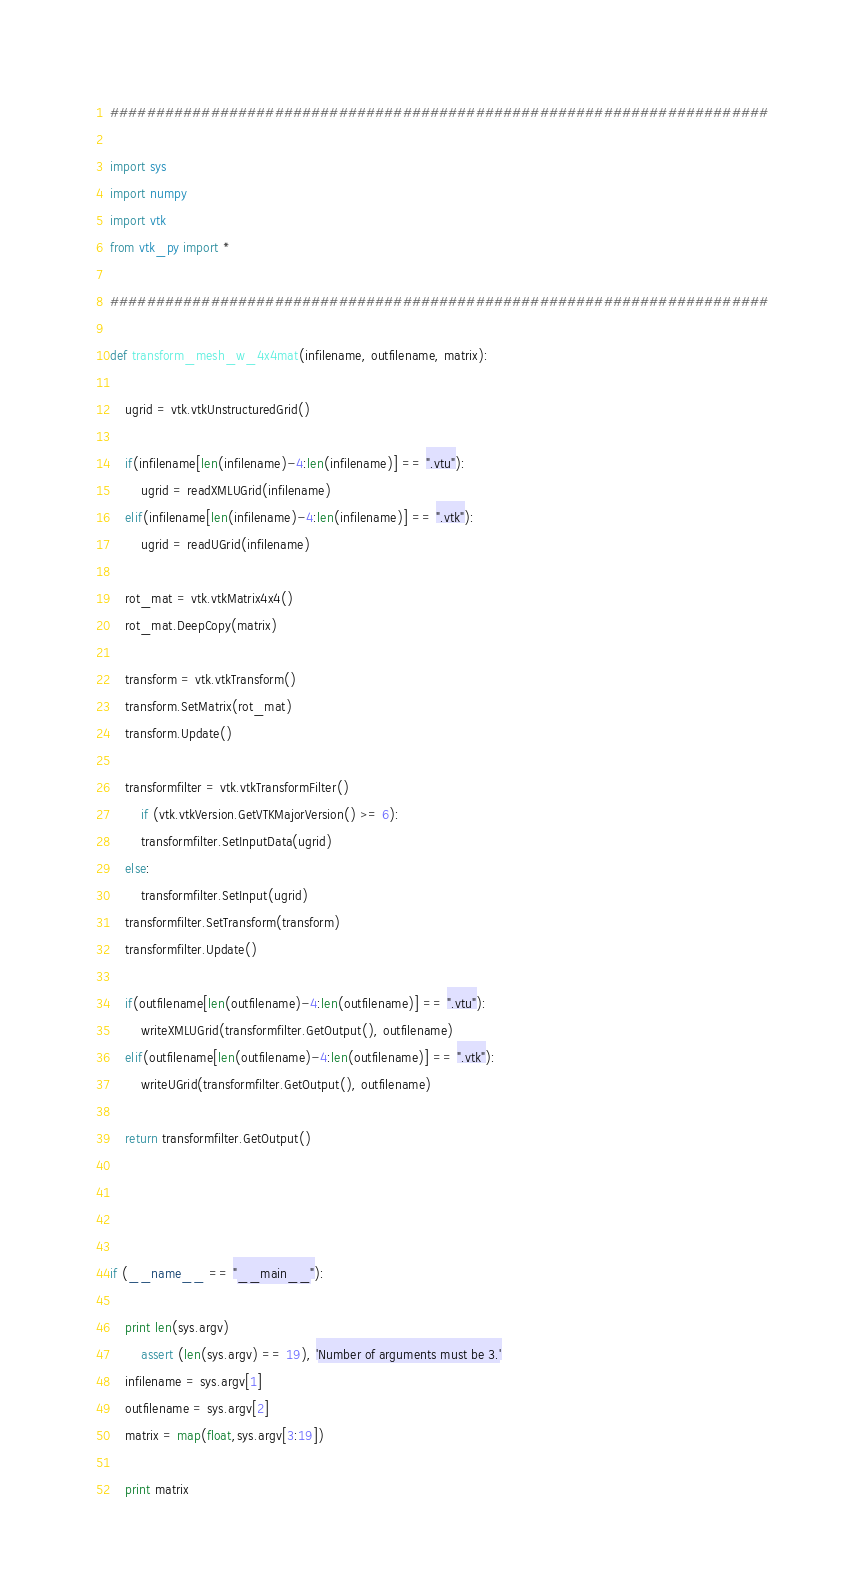Convert code to text. <code><loc_0><loc_0><loc_500><loc_500><_Python_>########################################################################

import sys
import numpy
import vtk
from vtk_py import *

########################################################################

def transform_mesh_w_4x4mat(infilename, outfilename, matrix):

	ugrid = vtk.vtkUnstructuredGrid()

	if(infilename[len(infilename)-4:len(infilename)] == ".vtu"):
		ugrid = readXMLUGrid(infilename)
	elif(infilename[len(infilename)-4:len(infilename)] == ".vtk"):
		ugrid = readUGrid(infilename)

	rot_mat = vtk.vtkMatrix4x4()
	rot_mat.DeepCopy(matrix)

	transform = vtk.vtkTransform()
	transform.SetMatrix(rot_mat)
	transform.Update()

	transformfilter = vtk.vtkTransformFilter()
    	if (vtk.vtkVersion.GetVTKMajorVersion() >= 6):
		transformfilter.SetInputData(ugrid)
	else:
		transformfilter.SetInput(ugrid)
	transformfilter.SetTransform(transform)
	transformfilter.Update()

	if(outfilename[len(outfilename)-4:len(outfilename)] == ".vtu"):
		writeXMLUGrid(transformfilter.GetOutput(), outfilename)
	elif(outfilename[len(outfilename)-4:len(outfilename)] == ".vtk"):
		writeUGrid(transformfilter.GetOutput(), outfilename)

	return transformfilter.GetOutput()




if (__name__ == "__main__"):
	
	print len(sys.argv)
    	assert (len(sys.argv) == 19), 'Number of arguments must be 3.'
	infilename = sys.argv[1]
	outfilename = sys.argv[2]
	matrix = map(float,sys.argv[3:19])

	print matrix
</code> 